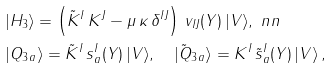<formula> <loc_0><loc_0><loc_500><loc_500>& | H _ { 3 } \rangle = \left ( \tilde { K } ^ { I } \, K ^ { J } - \mu \, \kappa \, \delta ^ { I J } \right ) \, v _ { I J } ( Y ) \, | V \rangle , \ n n \\ & | Q _ { 3 \, a } \rangle = \tilde { K } ^ { I } \, s ^ { I } _ { a } ( Y ) \, | V \rangle , \quad | \tilde { Q } _ { 3 \, a } \rangle = K ^ { I } \, \tilde { s } ^ { I } _ { a } ( Y ) \, | V \rangle \, ,</formula> 